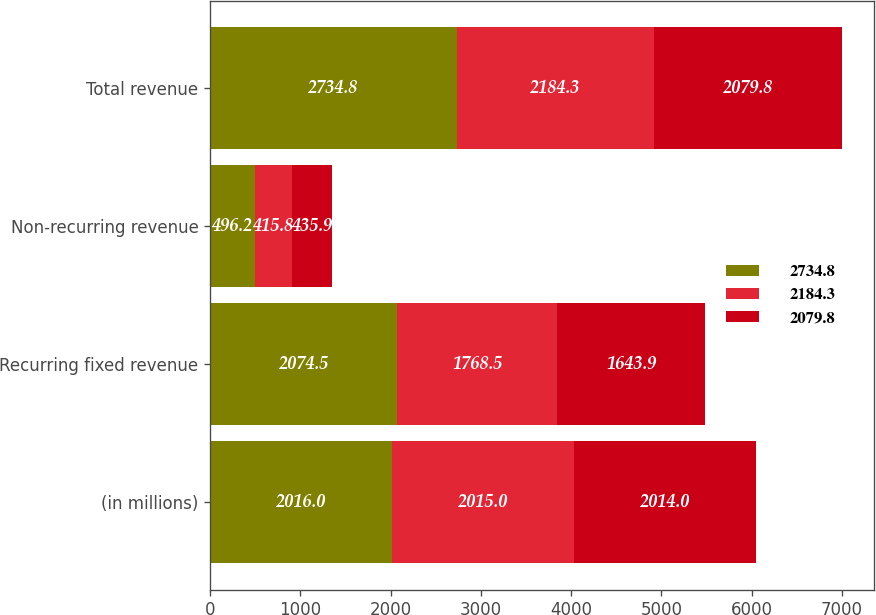Convert chart. <chart><loc_0><loc_0><loc_500><loc_500><stacked_bar_chart><ecel><fcel>(in millions)<fcel>Recurring fixed revenue<fcel>Non-recurring revenue<fcel>Total revenue<nl><fcel>2734.8<fcel>2016<fcel>2074.5<fcel>496.2<fcel>2734.8<nl><fcel>2184.3<fcel>2015<fcel>1768.5<fcel>415.8<fcel>2184.3<nl><fcel>2079.8<fcel>2014<fcel>1643.9<fcel>435.9<fcel>2079.8<nl></chart> 